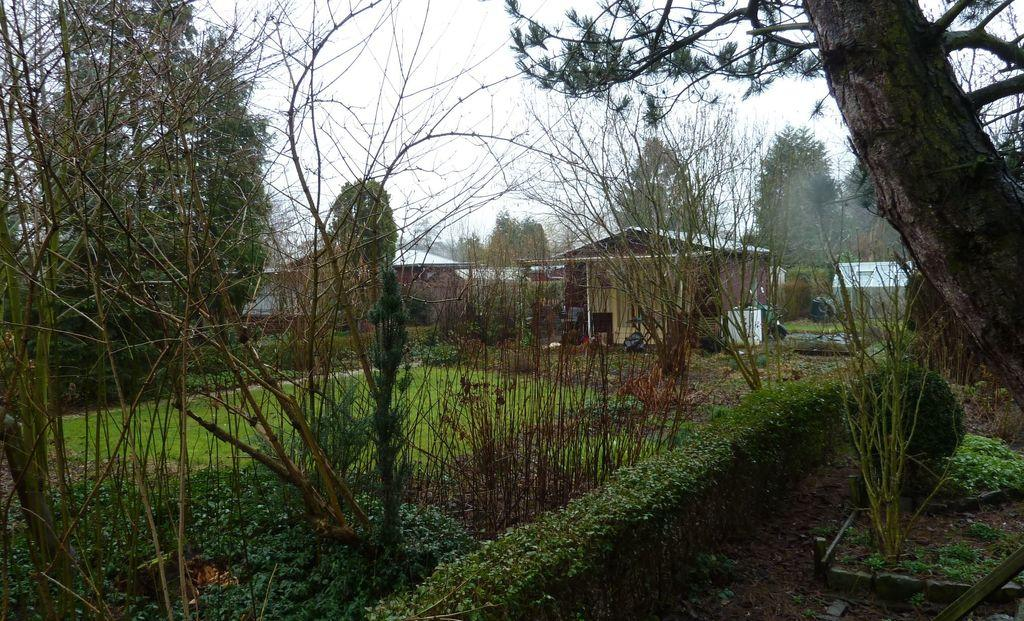What type of vegetation is visible in the image? There are trees in the image. What structures can be seen in the middle of the image? There are sheds in the middle of the image. What is visible at the top of the image? The sky is visible at the top of the image. How many steps can be seen leading up to the sheds in the image? There is no mention of steps leading up to the sheds in the image. Are there any roses growing near the trees in the image? There is no mention of roses in the image. Can you see any parents interacting with their children in the image? There is no mention of parents or children in the image. 